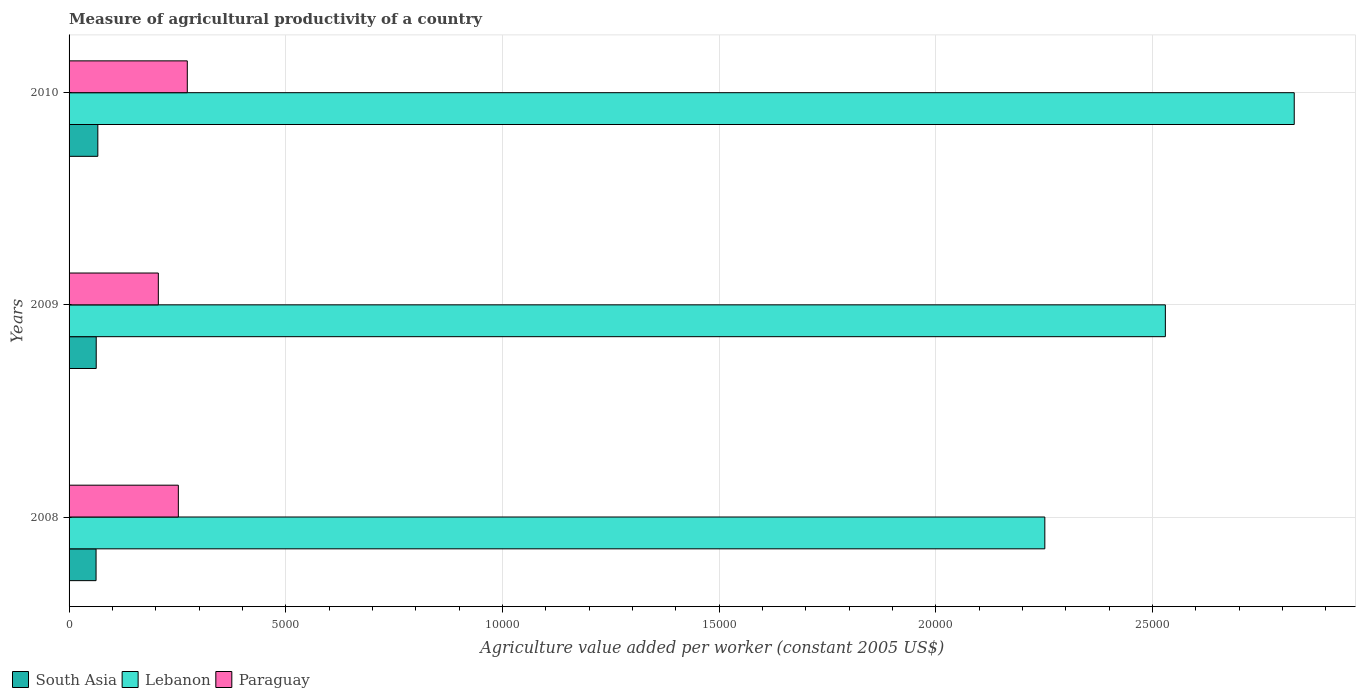How many bars are there on the 3rd tick from the top?
Provide a short and direct response. 3. In how many cases, is the number of bars for a given year not equal to the number of legend labels?
Offer a very short reply. 0. What is the measure of agricultural productivity in South Asia in 2009?
Your answer should be compact. 626.57. Across all years, what is the maximum measure of agricultural productivity in Lebanon?
Provide a short and direct response. 2.83e+04. Across all years, what is the minimum measure of agricultural productivity in Lebanon?
Offer a very short reply. 2.25e+04. In which year was the measure of agricultural productivity in Paraguay maximum?
Provide a succinct answer. 2010. What is the total measure of agricultural productivity in Paraguay in the graph?
Ensure brevity in your answer.  7309.89. What is the difference between the measure of agricultural productivity in Lebanon in 2008 and that in 2010?
Your answer should be compact. -5755.41. What is the difference between the measure of agricultural productivity in Paraguay in 2010 and the measure of agricultural productivity in South Asia in 2009?
Offer a terse response. 2101.82. What is the average measure of agricultural productivity in Paraguay per year?
Provide a succinct answer. 2436.63. In the year 2009, what is the difference between the measure of agricultural productivity in Paraguay and measure of agricultural productivity in South Asia?
Make the answer very short. 1433.21. In how many years, is the measure of agricultural productivity in Lebanon greater than 20000 US$?
Keep it short and to the point. 3. What is the ratio of the measure of agricultural productivity in South Asia in 2009 to that in 2010?
Ensure brevity in your answer.  0.94. Is the measure of agricultural productivity in South Asia in 2008 less than that in 2009?
Your answer should be compact. Yes. Is the difference between the measure of agricultural productivity in Paraguay in 2008 and 2009 greater than the difference between the measure of agricultural productivity in South Asia in 2008 and 2009?
Offer a terse response. Yes. What is the difference between the highest and the second highest measure of agricultural productivity in Lebanon?
Your answer should be compact. 2973.81. What is the difference between the highest and the lowest measure of agricultural productivity in South Asia?
Provide a short and direct response. 40.69. What does the 1st bar from the top in 2010 represents?
Provide a short and direct response. Paraguay. What does the 3rd bar from the bottom in 2010 represents?
Make the answer very short. Paraguay. Is it the case that in every year, the sum of the measure of agricultural productivity in Lebanon and measure of agricultural productivity in Paraguay is greater than the measure of agricultural productivity in South Asia?
Give a very brief answer. Yes. What is the difference between two consecutive major ticks on the X-axis?
Provide a short and direct response. 5000. How many legend labels are there?
Provide a succinct answer. 3. What is the title of the graph?
Your response must be concise. Measure of agricultural productivity of a country. What is the label or title of the X-axis?
Offer a very short reply. Agriculture value added per worker (constant 2005 US$). What is the Agriculture value added per worker (constant 2005 US$) in South Asia in 2008?
Your answer should be very brief. 622.93. What is the Agriculture value added per worker (constant 2005 US$) in Lebanon in 2008?
Give a very brief answer. 2.25e+04. What is the Agriculture value added per worker (constant 2005 US$) in Paraguay in 2008?
Give a very brief answer. 2521.73. What is the Agriculture value added per worker (constant 2005 US$) in South Asia in 2009?
Your answer should be compact. 626.57. What is the Agriculture value added per worker (constant 2005 US$) of Lebanon in 2009?
Provide a succinct answer. 2.53e+04. What is the Agriculture value added per worker (constant 2005 US$) of Paraguay in 2009?
Keep it short and to the point. 2059.78. What is the Agriculture value added per worker (constant 2005 US$) of South Asia in 2010?
Keep it short and to the point. 663.62. What is the Agriculture value added per worker (constant 2005 US$) of Lebanon in 2010?
Offer a very short reply. 2.83e+04. What is the Agriculture value added per worker (constant 2005 US$) in Paraguay in 2010?
Ensure brevity in your answer.  2728.39. Across all years, what is the maximum Agriculture value added per worker (constant 2005 US$) in South Asia?
Provide a succinct answer. 663.62. Across all years, what is the maximum Agriculture value added per worker (constant 2005 US$) in Lebanon?
Provide a short and direct response. 2.83e+04. Across all years, what is the maximum Agriculture value added per worker (constant 2005 US$) of Paraguay?
Your response must be concise. 2728.39. Across all years, what is the minimum Agriculture value added per worker (constant 2005 US$) of South Asia?
Make the answer very short. 622.93. Across all years, what is the minimum Agriculture value added per worker (constant 2005 US$) of Lebanon?
Offer a very short reply. 2.25e+04. Across all years, what is the minimum Agriculture value added per worker (constant 2005 US$) in Paraguay?
Your answer should be compact. 2059.78. What is the total Agriculture value added per worker (constant 2005 US$) of South Asia in the graph?
Your answer should be compact. 1913.12. What is the total Agriculture value added per worker (constant 2005 US$) in Lebanon in the graph?
Provide a short and direct response. 7.61e+04. What is the total Agriculture value added per worker (constant 2005 US$) in Paraguay in the graph?
Give a very brief answer. 7309.89. What is the difference between the Agriculture value added per worker (constant 2005 US$) in South Asia in 2008 and that in 2009?
Ensure brevity in your answer.  -3.63. What is the difference between the Agriculture value added per worker (constant 2005 US$) of Lebanon in 2008 and that in 2009?
Keep it short and to the point. -2781.59. What is the difference between the Agriculture value added per worker (constant 2005 US$) in Paraguay in 2008 and that in 2009?
Make the answer very short. 461.95. What is the difference between the Agriculture value added per worker (constant 2005 US$) of South Asia in 2008 and that in 2010?
Offer a terse response. -40.69. What is the difference between the Agriculture value added per worker (constant 2005 US$) in Lebanon in 2008 and that in 2010?
Keep it short and to the point. -5755.41. What is the difference between the Agriculture value added per worker (constant 2005 US$) in Paraguay in 2008 and that in 2010?
Your answer should be very brief. -206.66. What is the difference between the Agriculture value added per worker (constant 2005 US$) in South Asia in 2009 and that in 2010?
Offer a very short reply. -37.05. What is the difference between the Agriculture value added per worker (constant 2005 US$) in Lebanon in 2009 and that in 2010?
Your answer should be very brief. -2973.81. What is the difference between the Agriculture value added per worker (constant 2005 US$) in Paraguay in 2009 and that in 2010?
Make the answer very short. -668.61. What is the difference between the Agriculture value added per worker (constant 2005 US$) of South Asia in 2008 and the Agriculture value added per worker (constant 2005 US$) of Lebanon in 2009?
Your response must be concise. -2.47e+04. What is the difference between the Agriculture value added per worker (constant 2005 US$) of South Asia in 2008 and the Agriculture value added per worker (constant 2005 US$) of Paraguay in 2009?
Keep it short and to the point. -1436.84. What is the difference between the Agriculture value added per worker (constant 2005 US$) in Lebanon in 2008 and the Agriculture value added per worker (constant 2005 US$) in Paraguay in 2009?
Your answer should be very brief. 2.05e+04. What is the difference between the Agriculture value added per worker (constant 2005 US$) of South Asia in 2008 and the Agriculture value added per worker (constant 2005 US$) of Lebanon in 2010?
Offer a very short reply. -2.76e+04. What is the difference between the Agriculture value added per worker (constant 2005 US$) in South Asia in 2008 and the Agriculture value added per worker (constant 2005 US$) in Paraguay in 2010?
Make the answer very short. -2105.45. What is the difference between the Agriculture value added per worker (constant 2005 US$) of Lebanon in 2008 and the Agriculture value added per worker (constant 2005 US$) of Paraguay in 2010?
Your answer should be compact. 1.98e+04. What is the difference between the Agriculture value added per worker (constant 2005 US$) in South Asia in 2009 and the Agriculture value added per worker (constant 2005 US$) in Lebanon in 2010?
Provide a short and direct response. -2.76e+04. What is the difference between the Agriculture value added per worker (constant 2005 US$) of South Asia in 2009 and the Agriculture value added per worker (constant 2005 US$) of Paraguay in 2010?
Ensure brevity in your answer.  -2101.82. What is the difference between the Agriculture value added per worker (constant 2005 US$) in Lebanon in 2009 and the Agriculture value added per worker (constant 2005 US$) in Paraguay in 2010?
Your answer should be very brief. 2.26e+04. What is the average Agriculture value added per worker (constant 2005 US$) in South Asia per year?
Your response must be concise. 637.71. What is the average Agriculture value added per worker (constant 2005 US$) of Lebanon per year?
Provide a short and direct response. 2.54e+04. What is the average Agriculture value added per worker (constant 2005 US$) of Paraguay per year?
Provide a short and direct response. 2436.63. In the year 2008, what is the difference between the Agriculture value added per worker (constant 2005 US$) of South Asia and Agriculture value added per worker (constant 2005 US$) of Lebanon?
Make the answer very short. -2.19e+04. In the year 2008, what is the difference between the Agriculture value added per worker (constant 2005 US$) in South Asia and Agriculture value added per worker (constant 2005 US$) in Paraguay?
Your response must be concise. -1898.79. In the year 2008, what is the difference between the Agriculture value added per worker (constant 2005 US$) of Lebanon and Agriculture value added per worker (constant 2005 US$) of Paraguay?
Offer a very short reply. 2.00e+04. In the year 2009, what is the difference between the Agriculture value added per worker (constant 2005 US$) in South Asia and Agriculture value added per worker (constant 2005 US$) in Lebanon?
Give a very brief answer. -2.47e+04. In the year 2009, what is the difference between the Agriculture value added per worker (constant 2005 US$) of South Asia and Agriculture value added per worker (constant 2005 US$) of Paraguay?
Offer a terse response. -1433.21. In the year 2009, what is the difference between the Agriculture value added per worker (constant 2005 US$) of Lebanon and Agriculture value added per worker (constant 2005 US$) of Paraguay?
Ensure brevity in your answer.  2.32e+04. In the year 2010, what is the difference between the Agriculture value added per worker (constant 2005 US$) in South Asia and Agriculture value added per worker (constant 2005 US$) in Lebanon?
Offer a terse response. -2.76e+04. In the year 2010, what is the difference between the Agriculture value added per worker (constant 2005 US$) of South Asia and Agriculture value added per worker (constant 2005 US$) of Paraguay?
Your answer should be very brief. -2064.77. In the year 2010, what is the difference between the Agriculture value added per worker (constant 2005 US$) in Lebanon and Agriculture value added per worker (constant 2005 US$) in Paraguay?
Your answer should be very brief. 2.55e+04. What is the ratio of the Agriculture value added per worker (constant 2005 US$) of Lebanon in 2008 to that in 2009?
Your answer should be compact. 0.89. What is the ratio of the Agriculture value added per worker (constant 2005 US$) of Paraguay in 2008 to that in 2009?
Give a very brief answer. 1.22. What is the ratio of the Agriculture value added per worker (constant 2005 US$) of South Asia in 2008 to that in 2010?
Ensure brevity in your answer.  0.94. What is the ratio of the Agriculture value added per worker (constant 2005 US$) of Lebanon in 2008 to that in 2010?
Provide a short and direct response. 0.8. What is the ratio of the Agriculture value added per worker (constant 2005 US$) in Paraguay in 2008 to that in 2010?
Your answer should be very brief. 0.92. What is the ratio of the Agriculture value added per worker (constant 2005 US$) in South Asia in 2009 to that in 2010?
Offer a terse response. 0.94. What is the ratio of the Agriculture value added per worker (constant 2005 US$) of Lebanon in 2009 to that in 2010?
Your answer should be very brief. 0.89. What is the ratio of the Agriculture value added per worker (constant 2005 US$) of Paraguay in 2009 to that in 2010?
Your response must be concise. 0.75. What is the difference between the highest and the second highest Agriculture value added per worker (constant 2005 US$) in South Asia?
Keep it short and to the point. 37.05. What is the difference between the highest and the second highest Agriculture value added per worker (constant 2005 US$) of Lebanon?
Your answer should be very brief. 2973.81. What is the difference between the highest and the second highest Agriculture value added per worker (constant 2005 US$) in Paraguay?
Ensure brevity in your answer.  206.66. What is the difference between the highest and the lowest Agriculture value added per worker (constant 2005 US$) of South Asia?
Keep it short and to the point. 40.69. What is the difference between the highest and the lowest Agriculture value added per worker (constant 2005 US$) in Lebanon?
Offer a terse response. 5755.41. What is the difference between the highest and the lowest Agriculture value added per worker (constant 2005 US$) in Paraguay?
Ensure brevity in your answer.  668.61. 